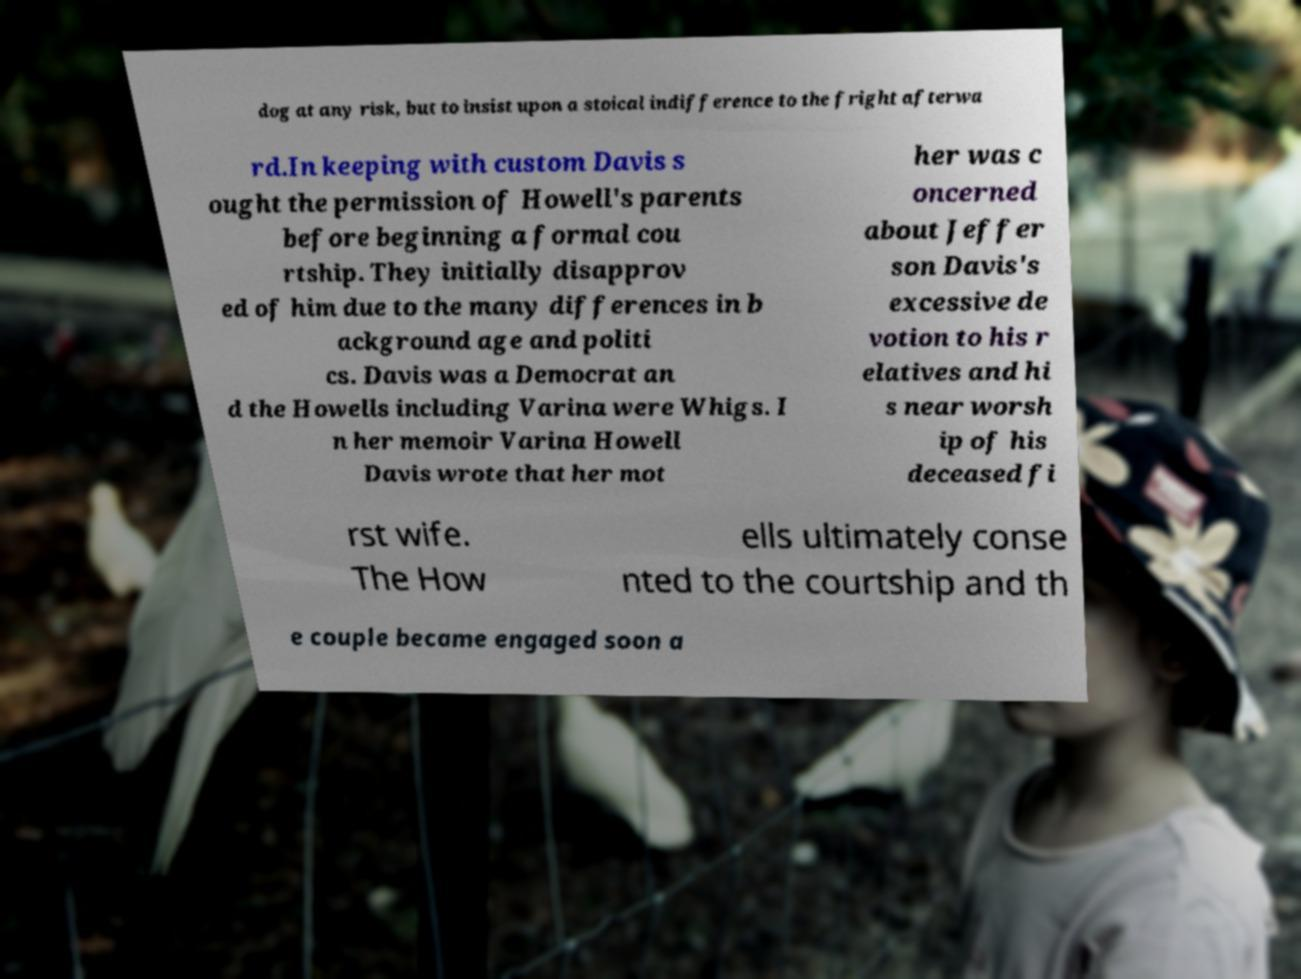Could you extract and type out the text from this image? dog at any risk, but to insist upon a stoical indifference to the fright afterwa rd.In keeping with custom Davis s ought the permission of Howell's parents before beginning a formal cou rtship. They initially disapprov ed of him due to the many differences in b ackground age and politi cs. Davis was a Democrat an d the Howells including Varina were Whigs. I n her memoir Varina Howell Davis wrote that her mot her was c oncerned about Jeffer son Davis's excessive de votion to his r elatives and hi s near worsh ip of his deceased fi rst wife. The How ells ultimately conse nted to the courtship and th e couple became engaged soon a 